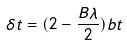Convert formula to latex. <formula><loc_0><loc_0><loc_500><loc_500>\delta t = ( 2 - \frac { B \lambda } { 2 } ) b t</formula> 